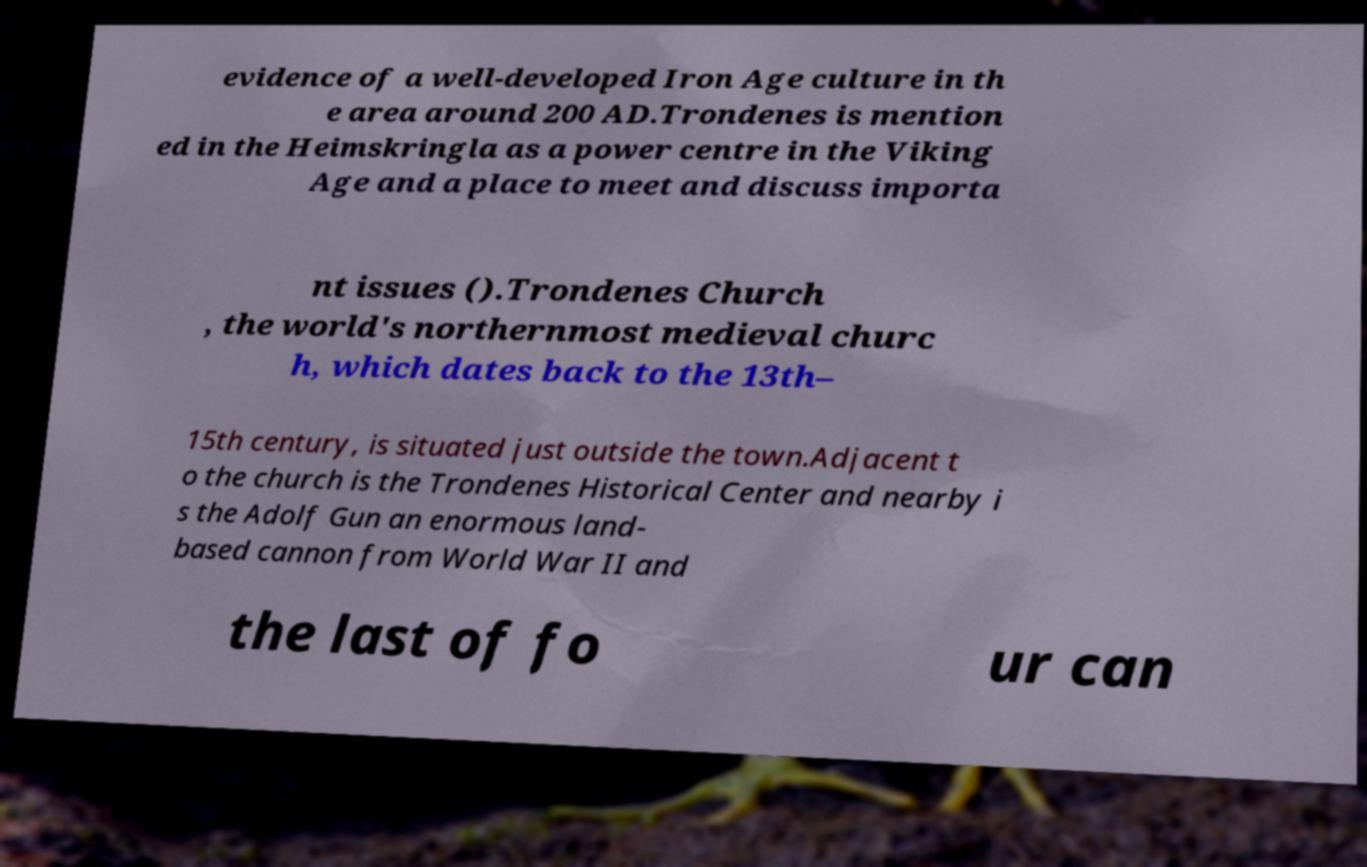Could you extract and type out the text from this image? evidence of a well-developed Iron Age culture in th e area around 200 AD.Trondenes is mention ed in the Heimskringla as a power centre in the Viking Age and a place to meet and discuss importa nt issues ().Trondenes Church , the world's northernmost medieval churc h, which dates back to the 13th– 15th century, is situated just outside the town.Adjacent t o the church is the Trondenes Historical Center and nearby i s the Adolf Gun an enormous land- based cannon from World War II and the last of fo ur can 